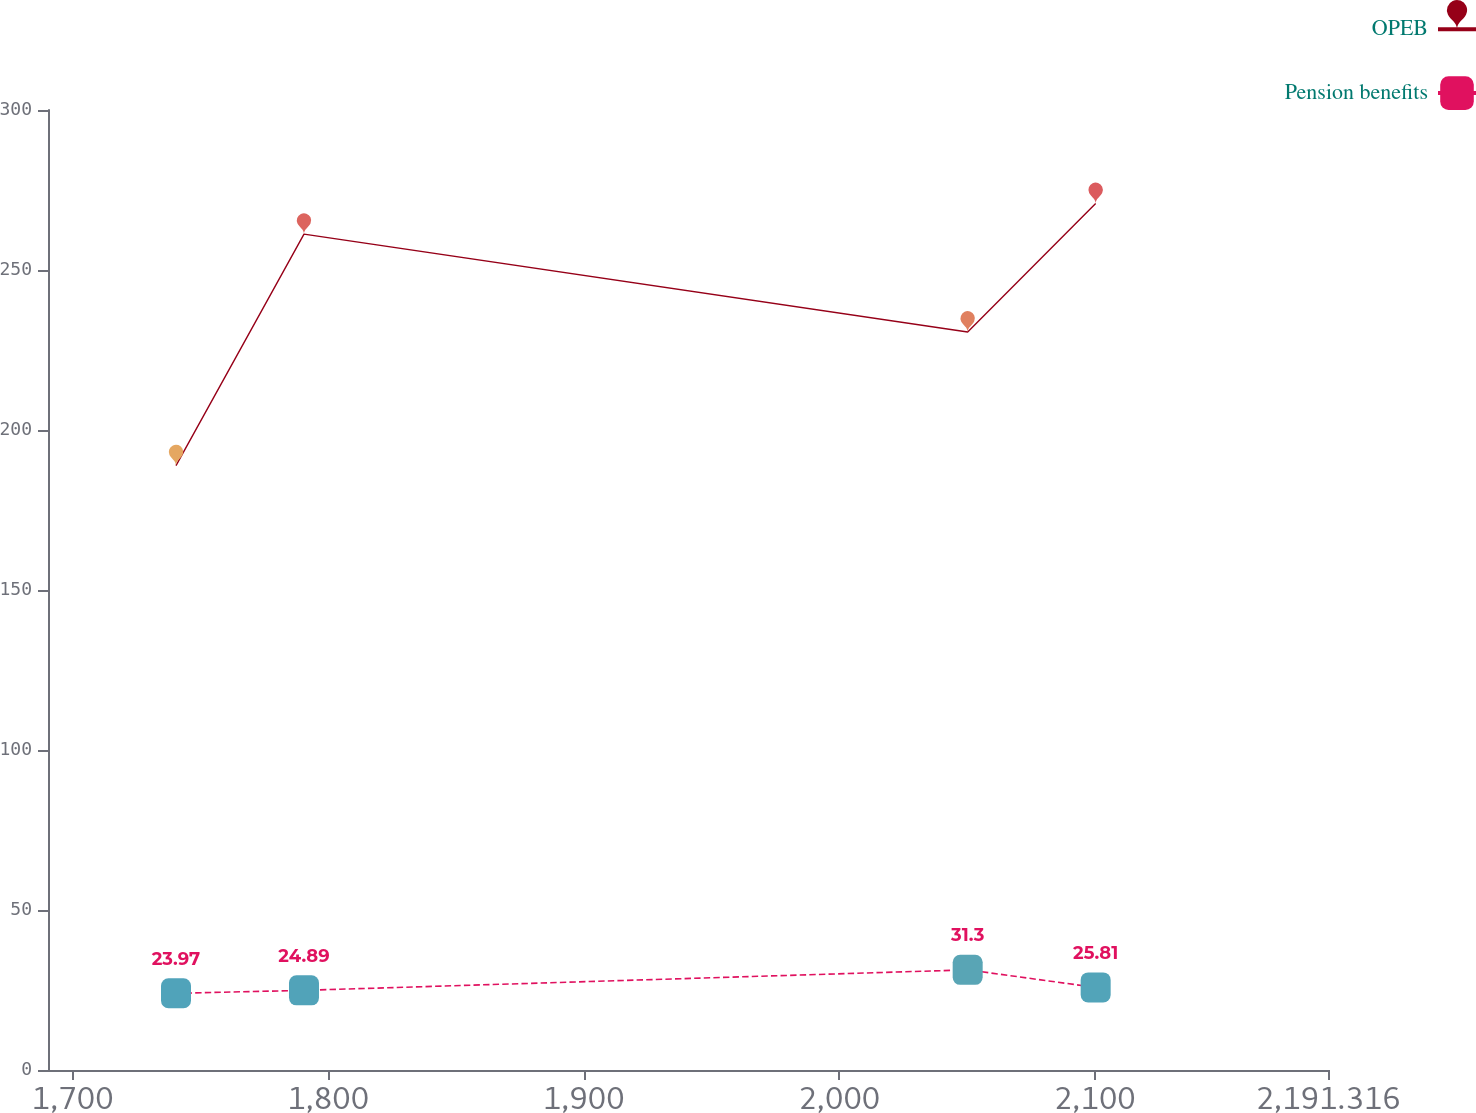Convert chart to OTSL. <chart><loc_0><loc_0><loc_500><loc_500><line_chart><ecel><fcel>OPEB<fcel>Pension benefits<nl><fcel>1740.47<fcel>188.87<fcel>23.97<nl><fcel>1790.56<fcel>261.21<fcel>24.89<nl><fcel>2050.3<fcel>230.62<fcel>31.3<nl><fcel>2100.39<fcel>270.78<fcel>25.81<nl><fcel>2241.41<fcel>284.62<fcel>33.16<nl></chart> 